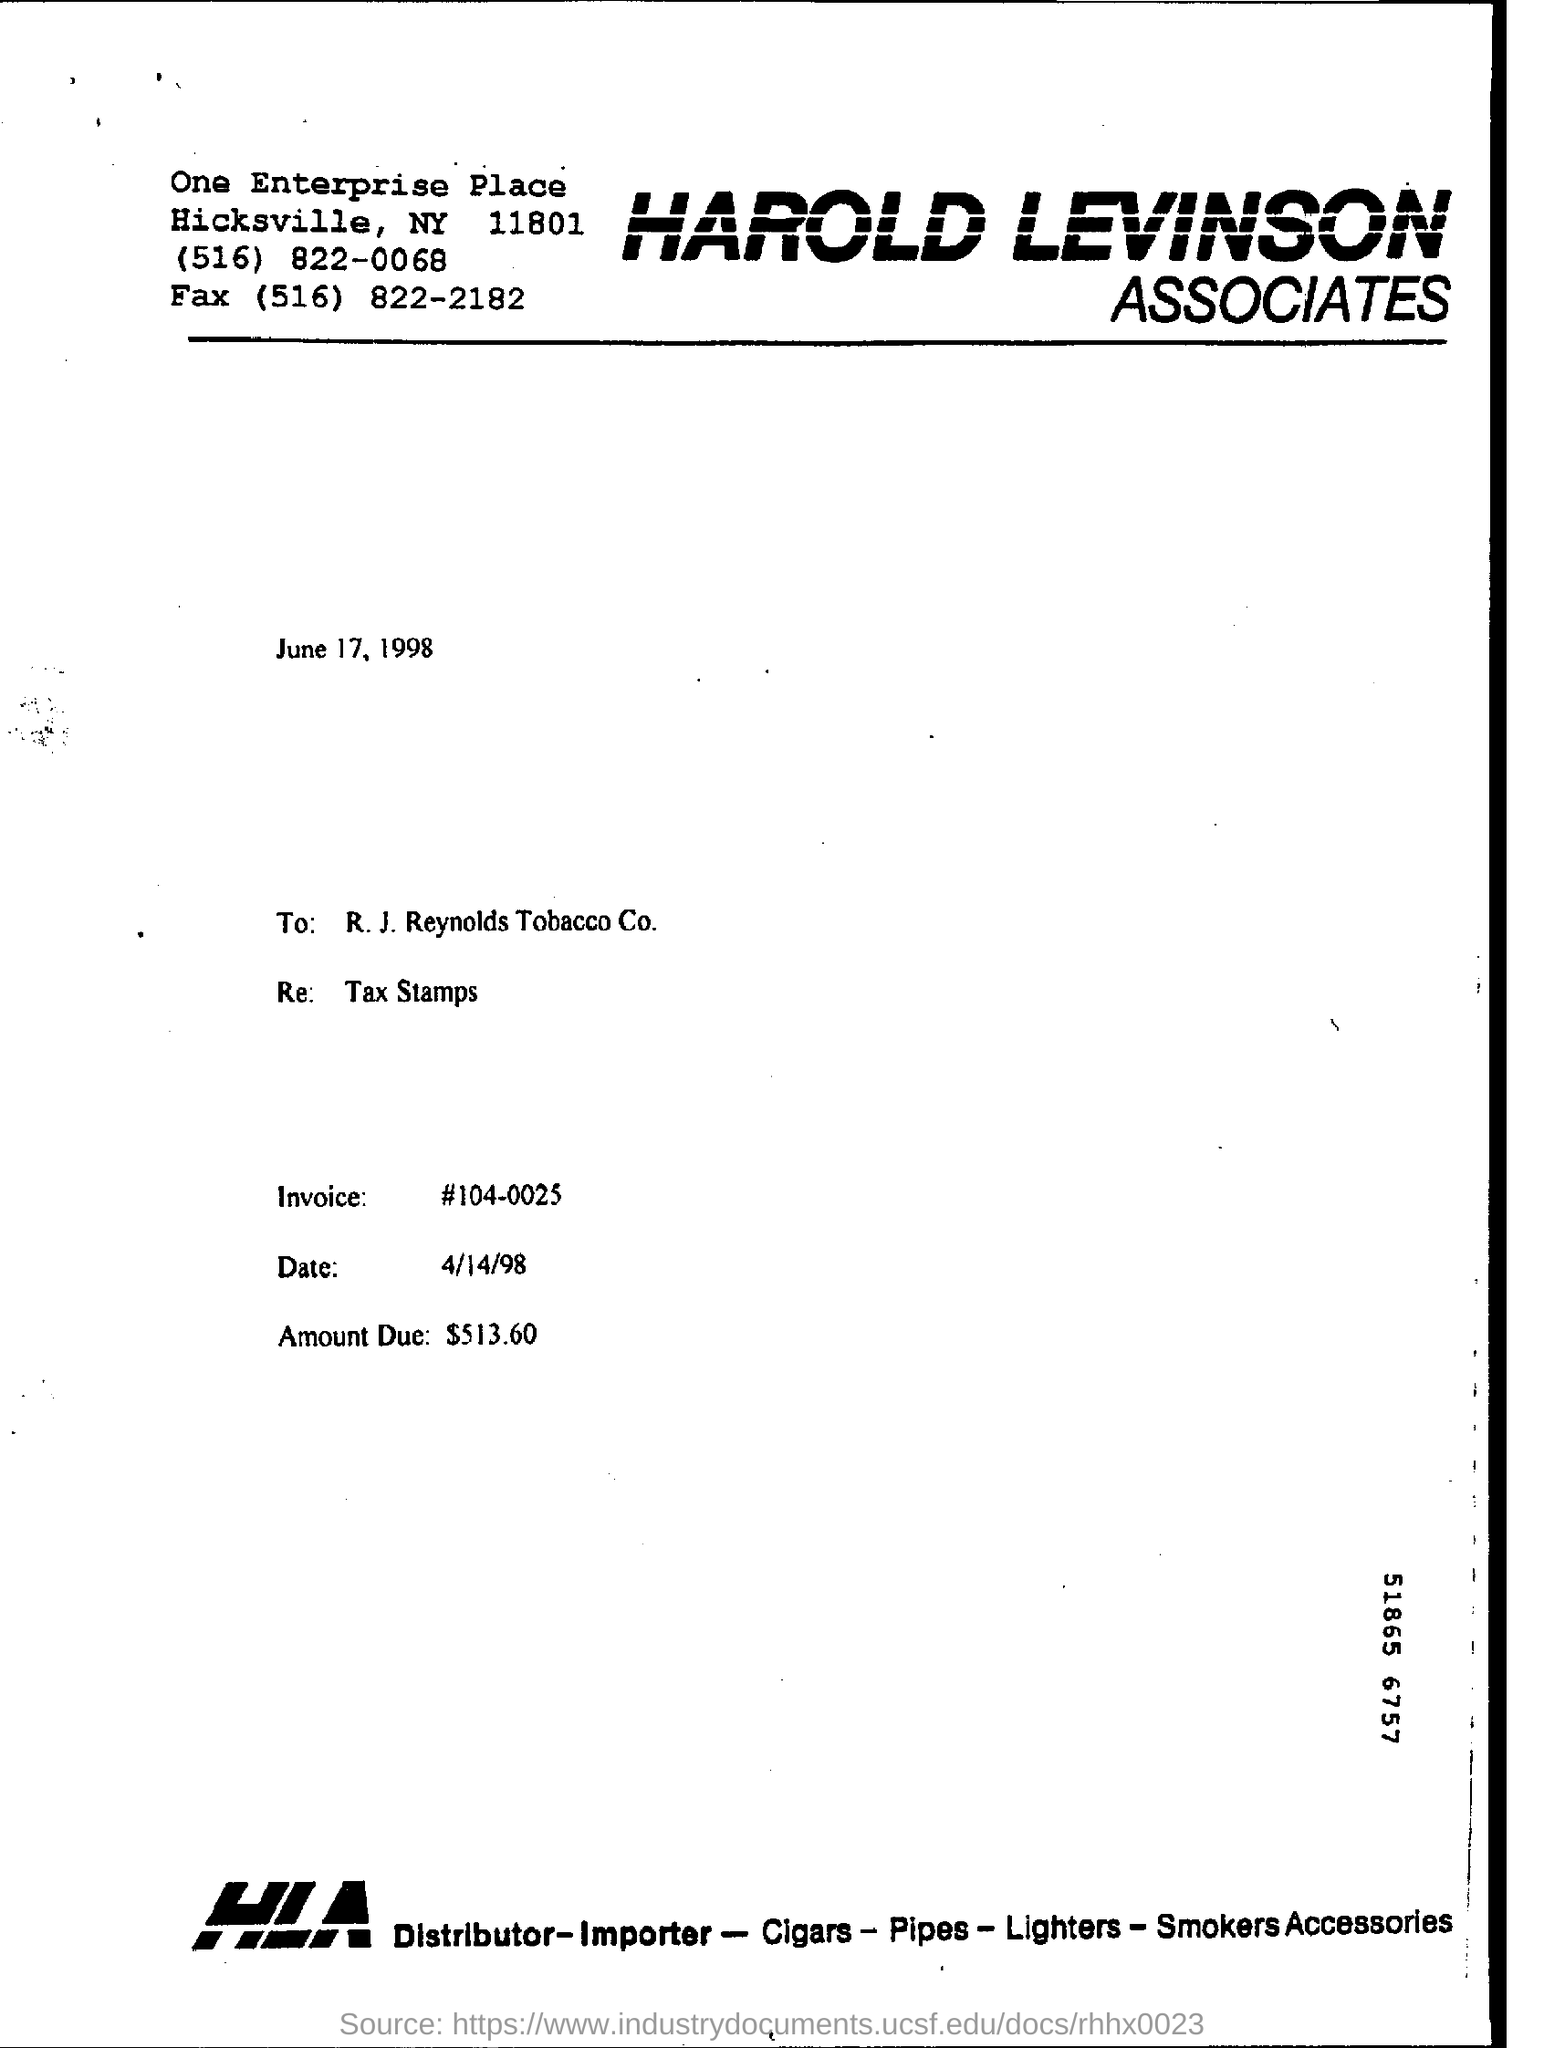Highlight a few significant elements in this photo. The full form of HLA is Human Leukocyte Antigen, which is a group of proteins that are expressed on the surface of cells and are involved in the immune system's recognition and response to foreign substances. It is mentioned in the Re: that tax stamps are present. The invoice number is 104-0025. The amount due is $513.60. The name of the company is Harold Levinson Associates. 